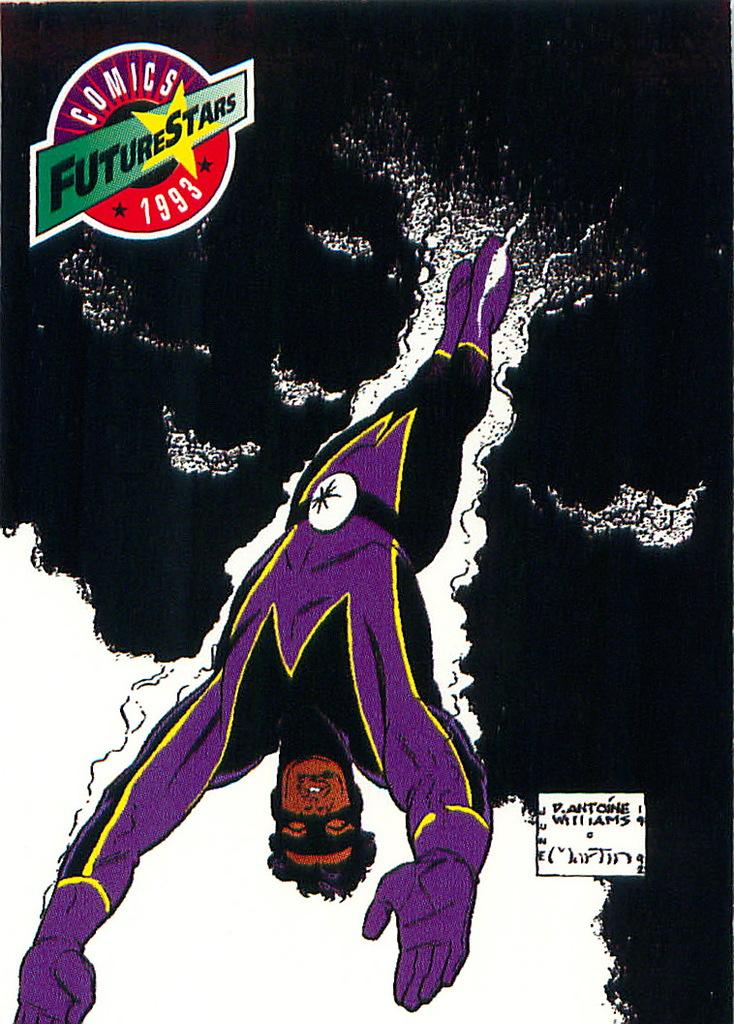What is present in the image that represents a visual display? There is a poster in the image. What is depicted on the poster? The poster features a future star. Where is the faucet located in the image? There is no faucet present in the image. What type of window is visible in the image? There is no window present in the image. 